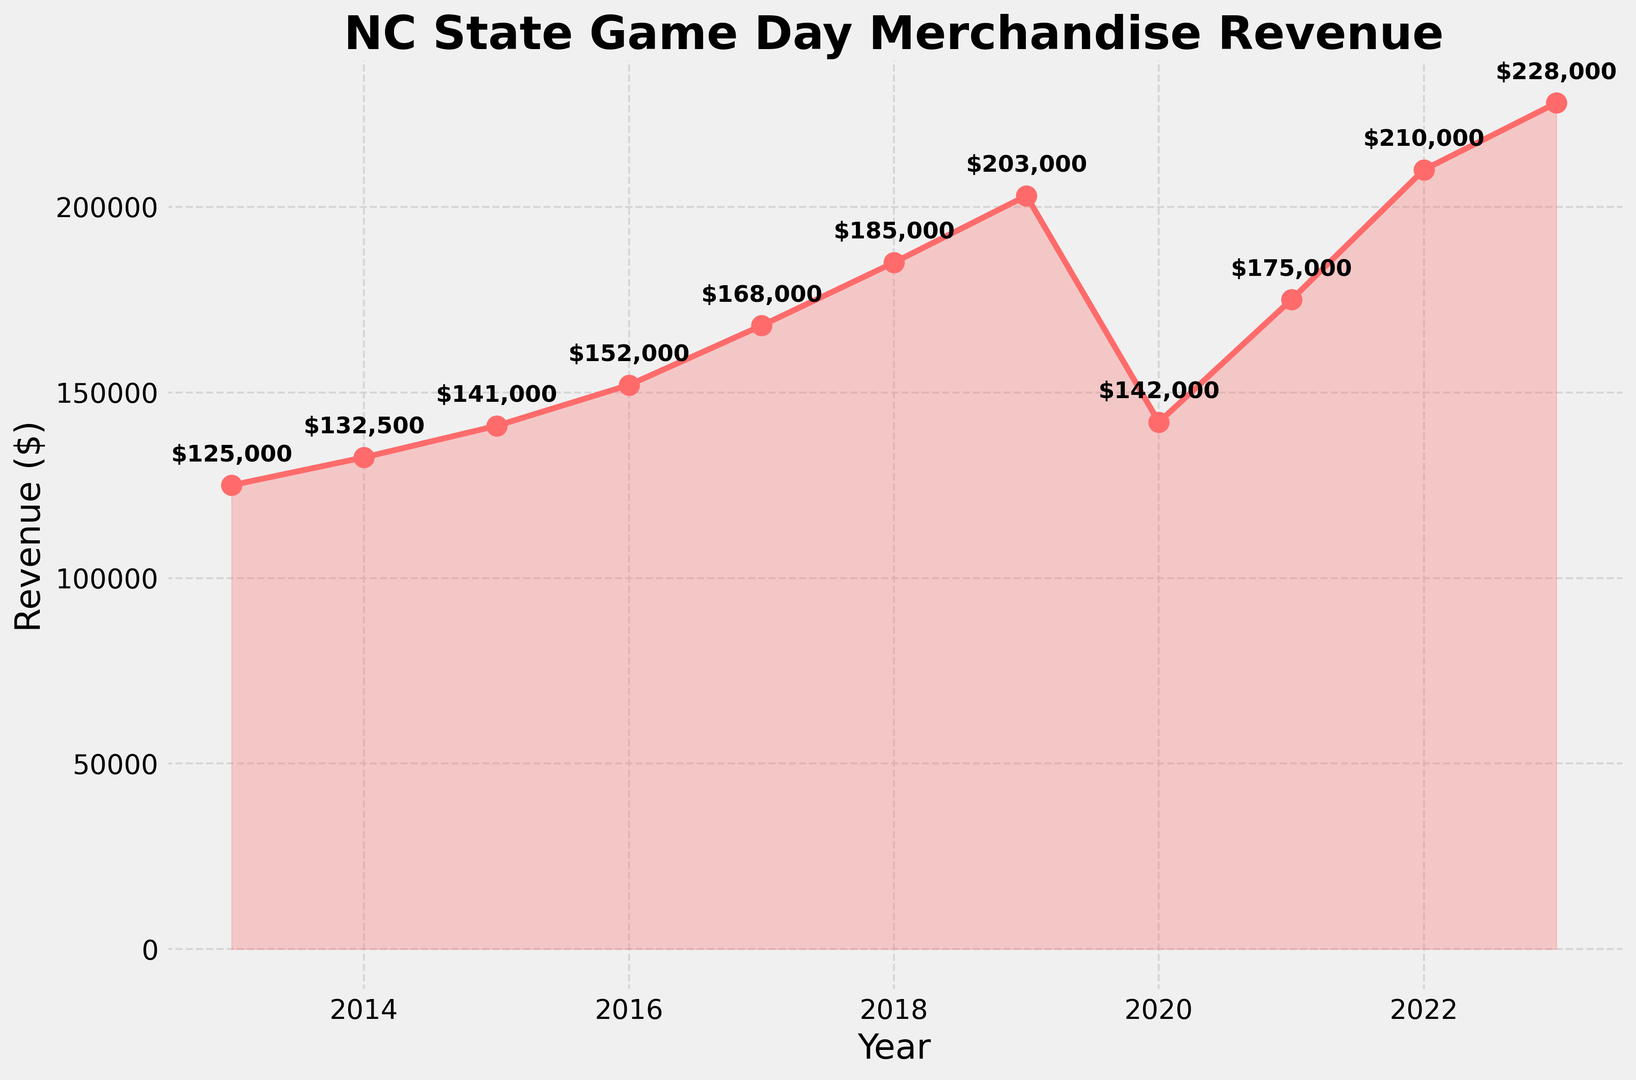What's the trend in revenue from 2013 to 2023? From 2013 to 2023, the revenue generally increased with a notable dip in 2020. Starting at $125,000 in 2013 and peaking at $228,000 in 2023.
Answer: Increasing with a dip in 2020 What year had the highest revenue? By looking at the peaks in the chart, 2023 had the highest revenue of $228,000.
Answer: 2023 How much did the revenue decrease in 2020 compared to 2019? The revenue in 2019 was $203,000 and in 2020 it was $142,000. The decrease can be calculated as $203,000 - $142,000 = $61,000.
Answer: $61,000 What was the revenue growth difference between 2013-2014 and 2022-2023? The growth from 2013 to 2014 was $132,500 - $125,000 = $7,500. The growth from 2022 to 2023 was $228,000 - $210,000 = $18,000.
Answer: $18,000 - $7,500 = $10,500 In what year did the revenue surpass $150,000 for the first time? By observing the upward trend line, the revenue first surpassed $150,000 in 2016.
Answer: 2016 How did the revenue in 2021 compare to 2020? The revenue in 2020 was $142,000 and in 2021 it was $175,000. This means revenue in 2021 increased compared to 2020.
Answer: Increased What's the average revenue from 2013 to 2023? To get the average, sum all revenues from 2013 to 2023 and divide by the number of years. The sum is $1,861,500 and dividing by 11 gives approximately $169,227.
Answer: Approximately $169,227 What is the percentage increase in revenue from 2013 to 2019? Revenue in 2013 was $125,000 and in 2019 it was $203,000. The percentage increase is (($203,000 - $125,000) / $125,000) * 100%. This calculates to be about 62.4%.
Answer: Approximately 62.4% How many years did the revenue increase consecutively before the 2020 drop? From 2013 to 2019 the revenue increased every year consecutively, making it a total of 6 years.
Answer: 6 years Which year showed the most significant single-year growth? By looking at the vertical distances between consecutive points, the year 2014-2015 shows significant growth, but the most significant leap is from 2018 to 2019 with an increase from $185,000 to $203,000.
Answer: 2018-2019 